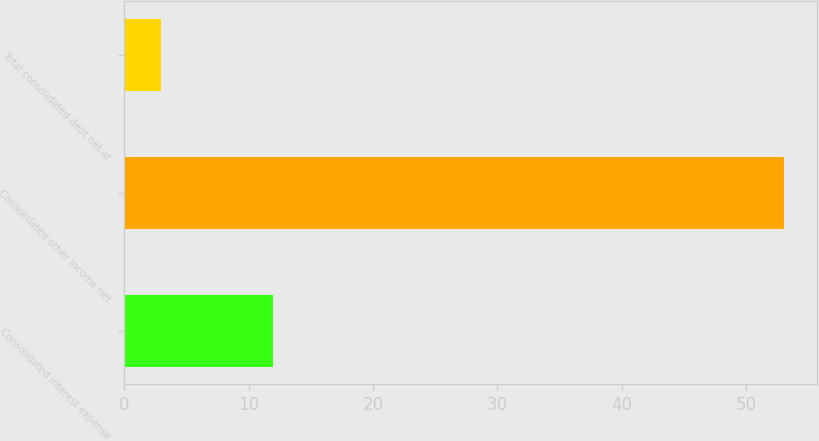<chart> <loc_0><loc_0><loc_500><loc_500><bar_chart><fcel>Consolidated interest expense<fcel>Consolidated other income net<fcel>Total consolidated debt net at<nl><fcel>12<fcel>53<fcel>3<nl></chart> 